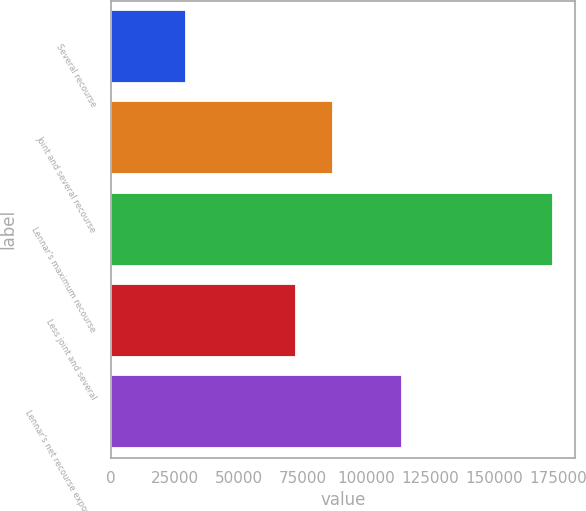<chart> <loc_0><loc_0><loc_500><loc_500><bar_chart><fcel>Several recourse<fcel>Joint and several recourse<fcel>Lennar's maximum recourse<fcel>Less joint and several<fcel>Lennar's net recourse exposure<nl><fcel>29454<fcel>86812.4<fcel>172850<fcel>72472.8<fcel>113972<nl></chart> 